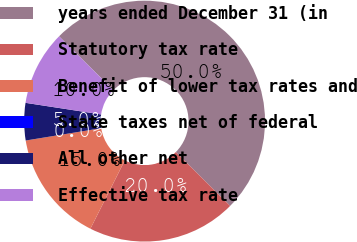<chart> <loc_0><loc_0><loc_500><loc_500><pie_chart><fcel>years ended December 31 (in<fcel>Statutory tax rate<fcel>Benefit of lower tax rates and<fcel>State taxes net of federal<fcel>All other net<fcel>Effective tax rate<nl><fcel>49.99%<fcel>20.0%<fcel>15.0%<fcel>0.0%<fcel>5.0%<fcel>10.0%<nl></chart> 